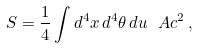Convert formula to latex. <formula><loc_0><loc_0><loc_500><loc_500>S = \frac { 1 } { 4 } \int d ^ { 4 } x \, d ^ { 4 } \theta \, d u \, \ A c ^ { 2 } \, ,</formula> 